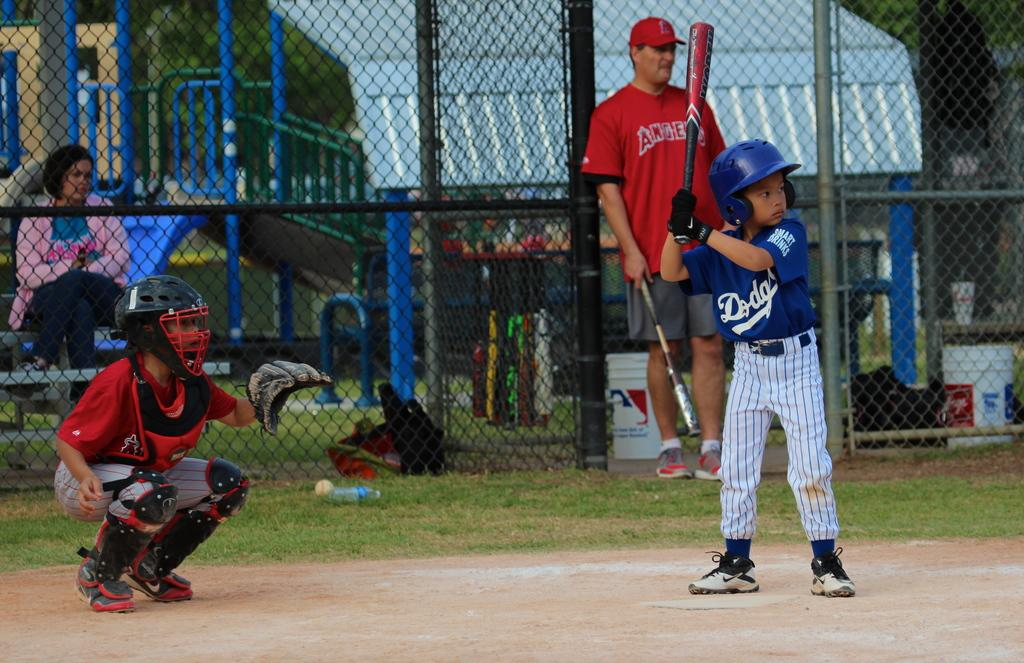<image>
Relay a brief, clear account of the picture shown. A coach and catcher for the Angels little league team with a batter from the Dodgers getting ready to swing. 